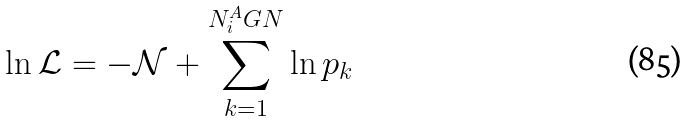<formula> <loc_0><loc_0><loc_500><loc_500>\ln \mathcal { L } = - \mathcal { N } + \sum _ { k = 1 } ^ { N _ { i } ^ { A } G N } \ln p _ { k }</formula> 